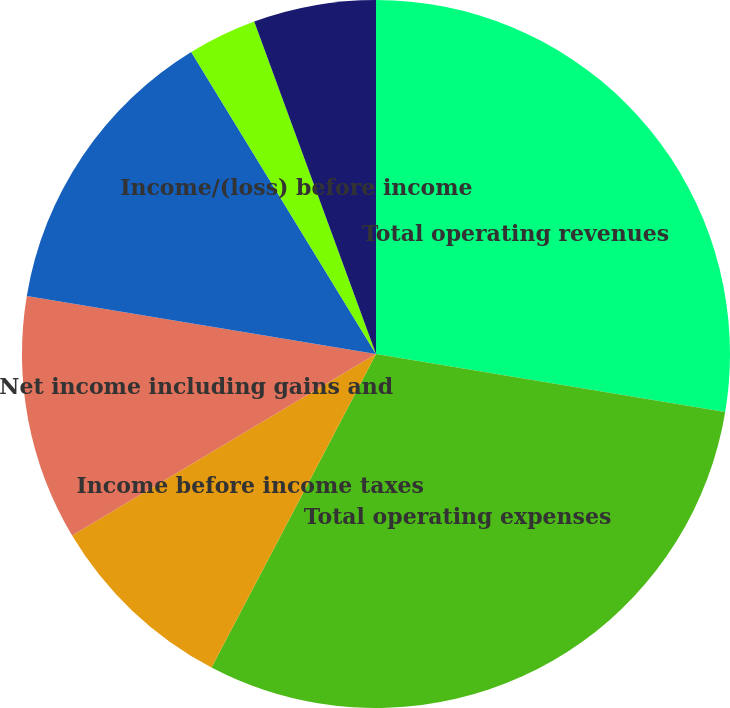<chart> <loc_0><loc_0><loc_500><loc_500><pie_chart><fcel>Total operating revenues<fcel>Total operating expenses<fcel>Income before income taxes<fcel>Net income including gains and<fcel>Net income attributable to<fcel>Income/(loss) before income<fcel>Net income/(loss) including<nl><fcel>27.62%<fcel>30.07%<fcel>8.74%<fcel>11.19%<fcel>13.64%<fcel>3.15%<fcel>5.59%<nl></chart> 